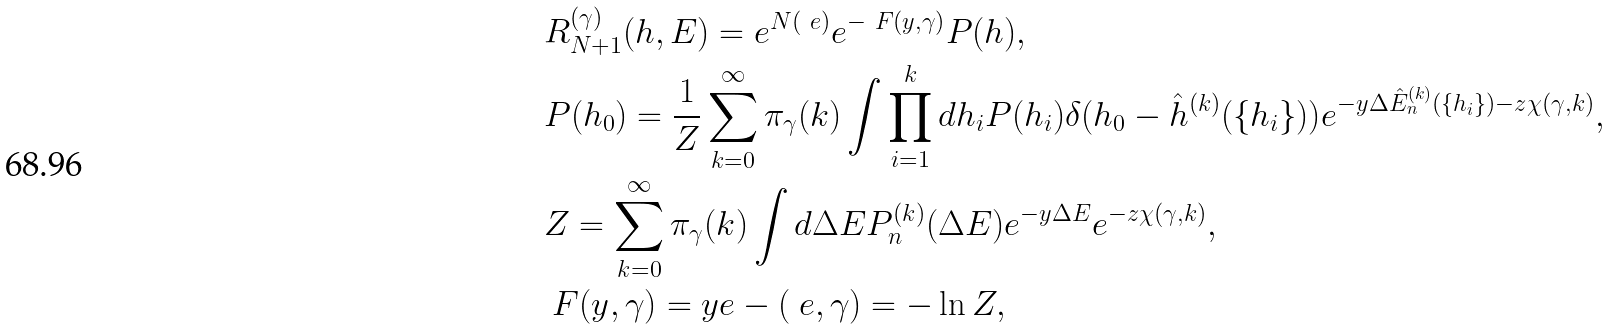<formula> <loc_0><loc_0><loc_500><loc_500>& R ^ { ( \gamma ) } _ { N + 1 } ( h , E ) = e ^ { N \L ( \ e ) } e ^ { - \ F ( y , \gamma ) } P ( h ) , \\ & P ( h _ { 0 } ) = \frac { 1 } { Z } \sum _ { k = 0 } ^ { \infty } \pi _ { \gamma } ( k ) \int \prod _ { i = 1 } ^ { k } d h _ { i } P ( h _ { i } ) \delta ( h _ { 0 } - \hat { h } ^ { ( k ) } ( \{ h _ { i } \} ) ) e ^ { - y \Delta \hat { E } _ { n } ^ { ( k ) } ( \{ h _ { i } \} ) - z \chi ( \gamma , k ) } , \\ & Z = \sum _ { k = 0 } ^ { \infty } \pi _ { \gamma } ( k ) \int d \Delta E P _ { n } ^ { ( k ) } ( \Delta E ) e ^ { - y \Delta E } e ^ { - z \chi ( \gamma , k ) } , \\ & \ F ( y , \gamma ) = y e - \L ( \ e , \gamma ) = - \ln Z ,</formula> 